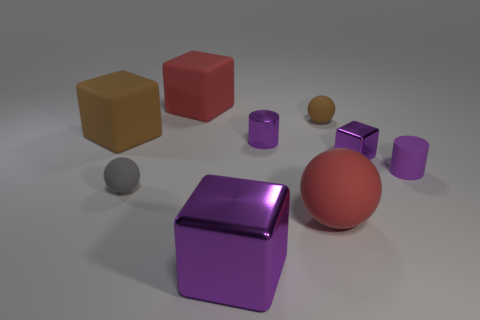Does the brown object that is to the left of the large purple metallic thing have the same shape as the large purple shiny thing to the right of the small gray rubber thing?
Provide a succinct answer. Yes. There is a purple thing that is both in front of the tiny purple block and on the right side of the brown ball; how big is it?
Keep it short and to the point. Small. The other metallic thing that is the same shape as the large purple metallic thing is what color?
Your response must be concise. Purple. The tiny rubber object that is behind the matte cylinder on the right side of the purple metal cylinder is what color?
Offer a terse response. Brown. There is a large purple object; what shape is it?
Your answer should be compact. Cube. What shape is the rubber object that is right of the tiny metallic cylinder and behind the small purple rubber object?
Offer a terse response. Sphere. The cylinder that is made of the same material as the large sphere is what color?
Your response must be concise. Purple. There is a brown matte thing to the left of the red matte thing that is on the right side of the red matte object that is behind the big brown block; what is its shape?
Provide a succinct answer. Cube. The red matte block is what size?
Provide a succinct answer. Large. There is a tiny object that is made of the same material as the small block; what shape is it?
Offer a terse response. Cylinder. 